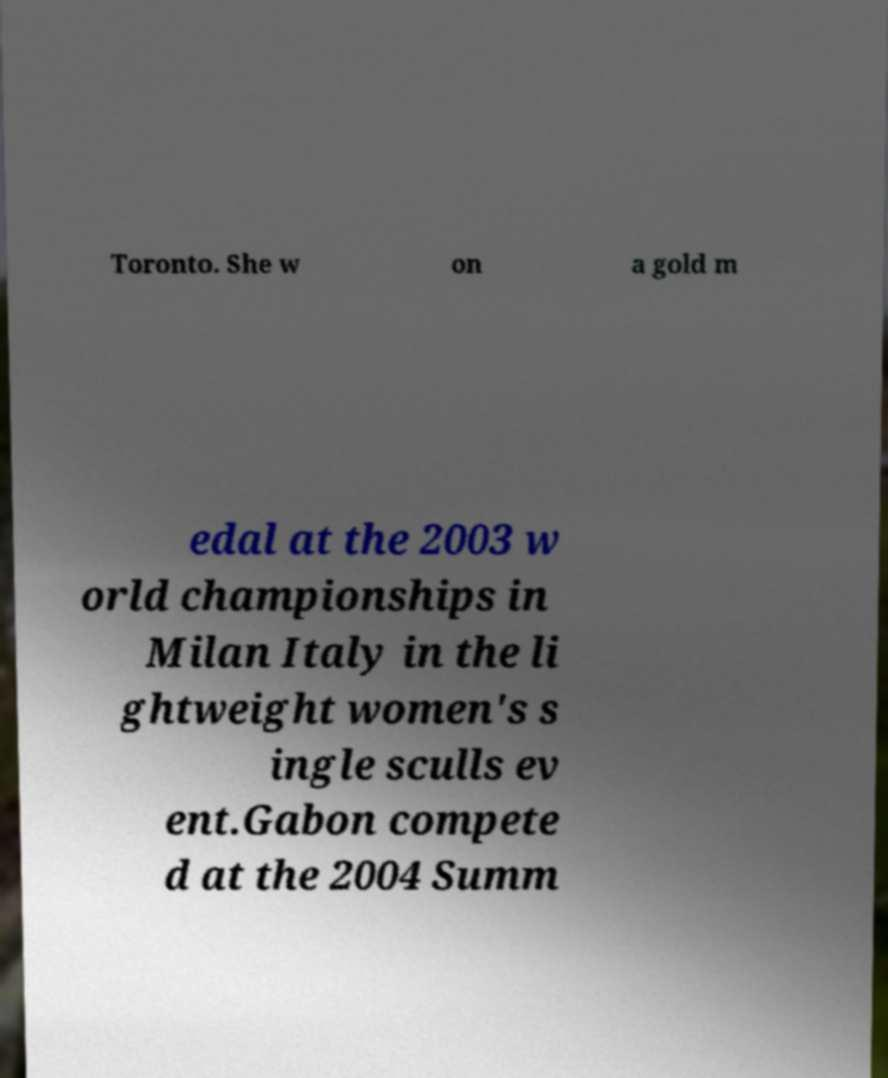Can you read and provide the text displayed in the image?This photo seems to have some interesting text. Can you extract and type it out for me? Toronto. She w on a gold m edal at the 2003 w orld championships in Milan Italy in the li ghtweight women's s ingle sculls ev ent.Gabon compete d at the 2004 Summ 